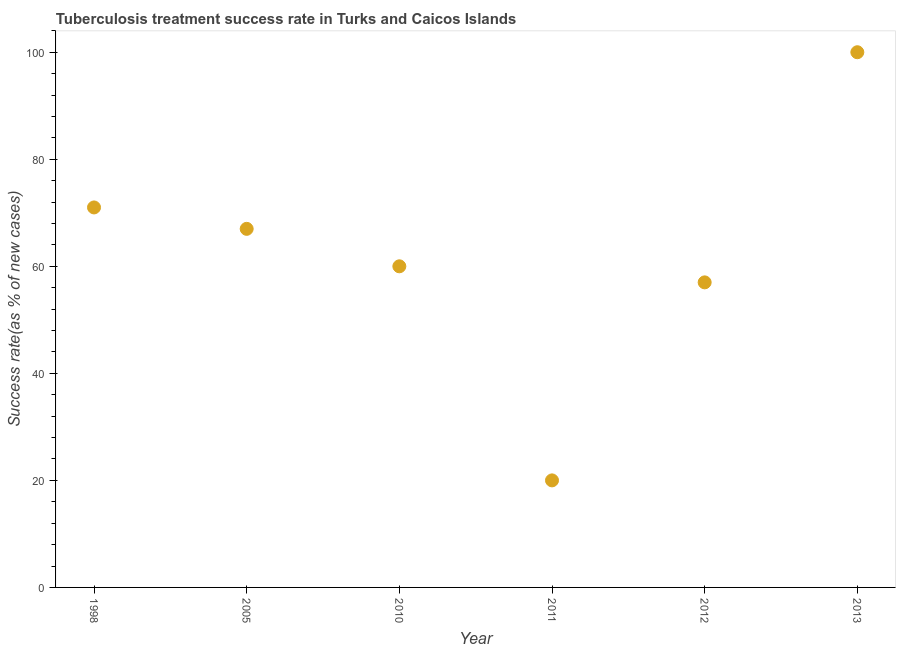What is the tuberculosis treatment success rate in 2013?
Your response must be concise. 100. Across all years, what is the maximum tuberculosis treatment success rate?
Make the answer very short. 100. Across all years, what is the minimum tuberculosis treatment success rate?
Offer a very short reply. 20. What is the sum of the tuberculosis treatment success rate?
Your answer should be compact. 375. What is the difference between the tuberculosis treatment success rate in 2010 and 2011?
Offer a terse response. 40. What is the average tuberculosis treatment success rate per year?
Your answer should be very brief. 62.5. What is the median tuberculosis treatment success rate?
Provide a succinct answer. 63.5. Do a majority of the years between 2013 and 2011 (inclusive) have tuberculosis treatment success rate greater than 76 %?
Offer a terse response. No. What is the ratio of the tuberculosis treatment success rate in 2005 to that in 2011?
Provide a succinct answer. 3.35. Is the difference between the tuberculosis treatment success rate in 2011 and 2013 greater than the difference between any two years?
Your answer should be compact. Yes. What is the difference between the highest and the second highest tuberculosis treatment success rate?
Keep it short and to the point. 29. Is the sum of the tuberculosis treatment success rate in 2012 and 2013 greater than the maximum tuberculosis treatment success rate across all years?
Your answer should be very brief. Yes. What is the difference between the highest and the lowest tuberculosis treatment success rate?
Keep it short and to the point. 80. Does the tuberculosis treatment success rate monotonically increase over the years?
Provide a succinct answer. No. How many years are there in the graph?
Make the answer very short. 6. What is the title of the graph?
Your answer should be compact. Tuberculosis treatment success rate in Turks and Caicos Islands. What is the label or title of the X-axis?
Provide a succinct answer. Year. What is the label or title of the Y-axis?
Your answer should be very brief. Success rate(as % of new cases). What is the Success rate(as % of new cases) in 1998?
Provide a short and direct response. 71. What is the Success rate(as % of new cases) in 2005?
Offer a very short reply. 67. What is the Success rate(as % of new cases) in 2010?
Ensure brevity in your answer.  60. What is the Success rate(as % of new cases) in 2011?
Make the answer very short. 20. What is the Success rate(as % of new cases) in 2012?
Ensure brevity in your answer.  57. What is the Success rate(as % of new cases) in 2013?
Keep it short and to the point. 100. What is the difference between the Success rate(as % of new cases) in 1998 and 2011?
Ensure brevity in your answer.  51. What is the difference between the Success rate(as % of new cases) in 2005 and 2012?
Offer a very short reply. 10. What is the difference between the Success rate(as % of new cases) in 2005 and 2013?
Provide a short and direct response. -33. What is the difference between the Success rate(as % of new cases) in 2011 and 2012?
Keep it short and to the point. -37. What is the difference between the Success rate(as % of new cases) in 2011 and 2013?
Provide a succinct answer. -80. What is the difference between the Success rate(as % of new cases) in 2012 and 2013?
Your answer should be compact. -43. What is the ratio of the Success rate(as % of new cases) in 1998 to that in 2005?
Ensure brevity in your answer.  1.06. What is the ratio of the Success rate(as % of new cases) in 1998 to that in 2010?
Your answer should be very brief. 1.18. What is the ratio of the Success rate(as % of new cases) in 1998 to that in 2011?
Give a very brief answer. 3.55. What is the ratio of the Success rate(as % of new cases) in 1998 to that in 2012?
Offer a very short reply. 1.25. What is the ratio of the Success rate(as % of new cases) in 1998 to that in 2013?
Your response must be concise. 0.71. What is the ratio of the Success rate(as % of new cases) in 2005 to that in 2010?
Keep it short and to the point. 1.12. What is the ratio of the Success rate(as % of new cases) in 2005 to that in 2011?
Offer a very short reply. 3.35. What is the ratio of the Success rate(as % of new cases) in 2005 to that in 2012?
Make the answer very short. 1.18. What is the ratio of the Success rate(as % of new cases) in 2005 to that in 2013?
Ensure brevity in your answer.  0.67. What is the ratio of the Success rate(as % of new cases) in 2010 to that in 2011?
Give a very brief answer. 3. What is the ratio of the Success rate(as % of new cases) in 2010 to that in 2012?
Keep it short and to the point. 1.05. What is the ratio of the Success rate(as % of new cases) in 2011 to that in 2012?
Your answer should be compact. 0.35. What is the ratio of the Success rate(as % of new cases) in 2012 to that in 2013?
Keep it short and to the point. 0.57. 